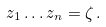Convert formula to latex. <formula><loc_0><loc_0><loc_500><loc_500>z _ { 1 } \dots z _ { n } = \zeta \, .</formula> 